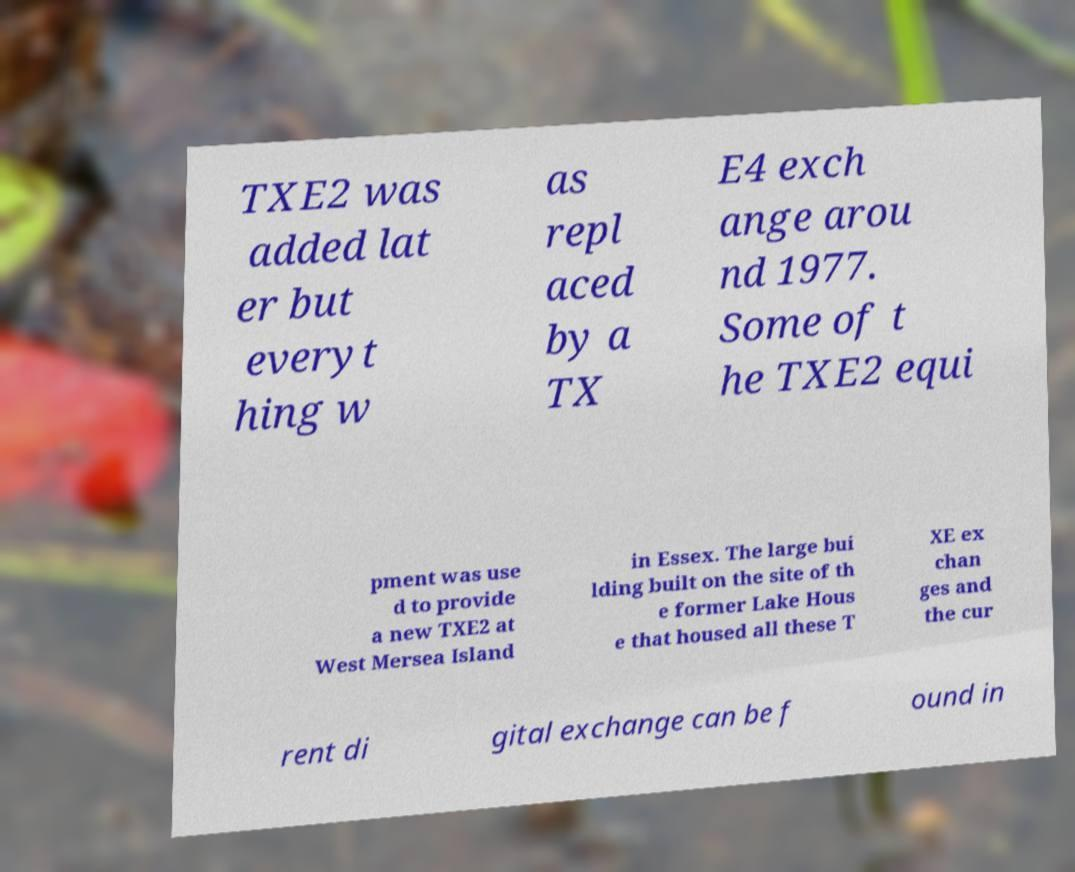What messages or text are displayed in this image? I need them in a readable, typed format. TXE2 was added lat er but everyt hing w as repl aced by a TX E4 exch ange arou nd 1977. Some of t he TXE2 equi pment was use d to provide a new TXE2 at West Mersea Island in Essex. The large bui lding built on the site of th e former Lake Hous e that housed all these T XE ex chan ges and the cur rent di gital exchange can be f ound in 